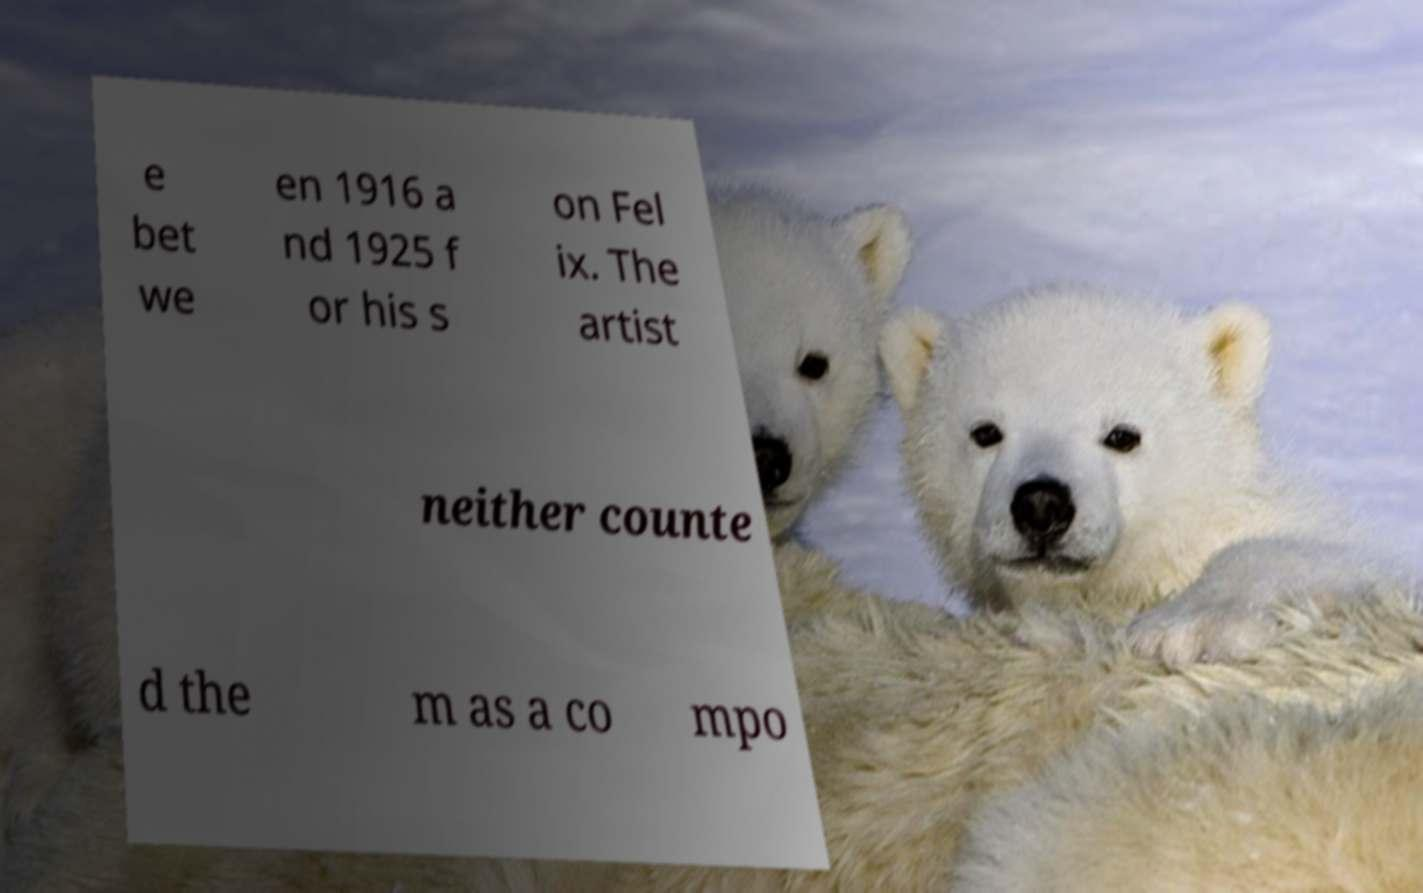Could you assist in decoding the text presented in this image and type it out clearly? e bet we en 1916 a nd 1925 f or his s on Fel ix. The artist neither counte d the m as a co mpo 